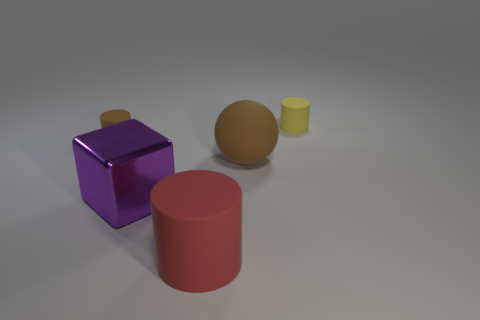What number of other things are there of the same shape as the purple object?
Give a very brief answer. 0. There is a purple metallic thing; is its shape the same as the brown object to the left of the cube?
Give a very brief answer. No. Are there any other things that have the same material as the big cube?
Give a very brief answer. No. What material is the tiny brown thing that is the same shape as the tiny yellow rubber object?
Provide a succinct answer. Rubber. How many small objects are either cyan matte cylinders or red rubber cylinders?
Offer a very short reply. 0. Are there fewer metal things right of the ball than small yellow matte cylinders to the right of the red cylinder?
Provide a succinct answer. Yes. What number of objects are either purple metal blocks or tiny gray rubber blocks?
Offer a terse response. 1. There is a small brown thing; what number of cylinders are to the right of it?
Offer a terse response. 2. Does the big matte cylinder have the same color as the block?
Your answer should be compact. No. There is a yellow object that is the same material as the red thing; what shape is it?
Give a very brief answer. Cylinder. 